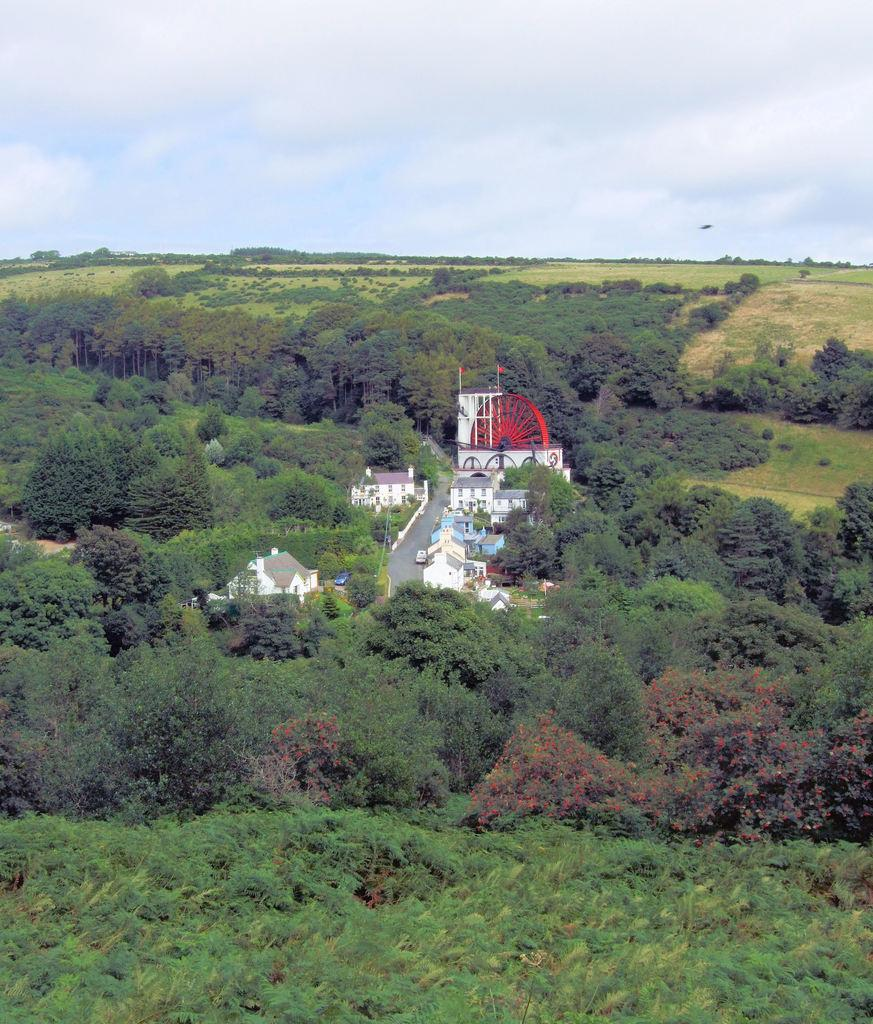What type of natural elements can be seen in the image? There are trees in the image. What type of man-made structures are present in the image? There are buildings in the image. What is located in the middle of the image? There is a road in the middle of the image. What type of symbolic objects can be seen in the image? There are flags in the image. What color object is present in the image? There is a red color object in the image. What is visible in the background of the image? The sky is visible in the background of the image. What type of weather can be inferred from the image? Clouds are present in the sky, suggesting that it might be a partly cloudy day. Can you provide any legal advice regarding the flags in the image? There is no need for legal advice in the context of the image, as it only depicts flags and does not involve any legal matters. 